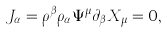<formula> <loc_0><loc_0><loc_500><loc_500>J _ { \alpha } = \rho ^ { \beta } \rho _ { \alpha } \Psi ^ { \mu } \partial _ { \beta } X _ { \mu } = 0 ,</formula> 